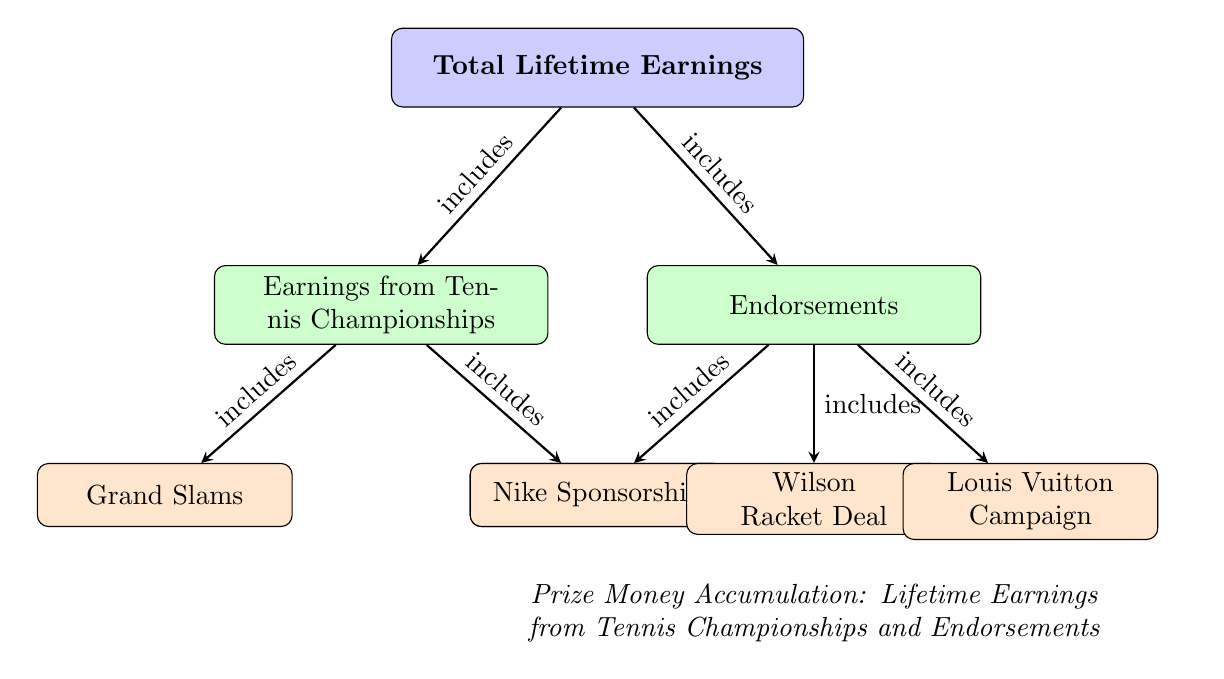What are the two main sources of total lifetime earnings? The diagram shows that total lifetime earnings come from two main sources: earnings from tennis championships and endorsements. These are the first two sub-nodes directly connected to the total lifetime earnings node.
Answer: earnings from tennis championships and endorsements How many categories are included under earnings from tennis championships? The diagram indicates that earnings from tennis championships include two categories: Grand Slams and ATP Tour Events. These are positioned as sub-nodes beneath the earnings from tennis championships node.
Answer: 2 What type of endorsement is listed first under endorsements? According to the diagram, the first endorsement listed is the Nike Sponsorship, as it is the first sub-node connected to the endorsements node.
Answer: Nike Sponsorship Which category includes the most specific types of earnings? The earnings from tennis championships node includes sub-categories, making it more specific than endorsements, which lists only the types of endorsements without further subdivision.
Answer: earnings from tennis championships How are endorsements and earnings from tennis championships related to total lifetime earnings? The diagram illustrates that both endorsements and earnings from tennis championships are included in the total lifetime earnings. They are connected by arrows indicating that they contribute to the total amount.
Answer: included in total lifetime earnings What is the direct relationship between ATP Tour Events and tennis championships? The diagram shows that ATP Tour Events is a sub-node of earnings from tennis championships, indicating that ATP Tour Events are a specific category under the umbrella of earnings from tennis championships.
Answer: includes 